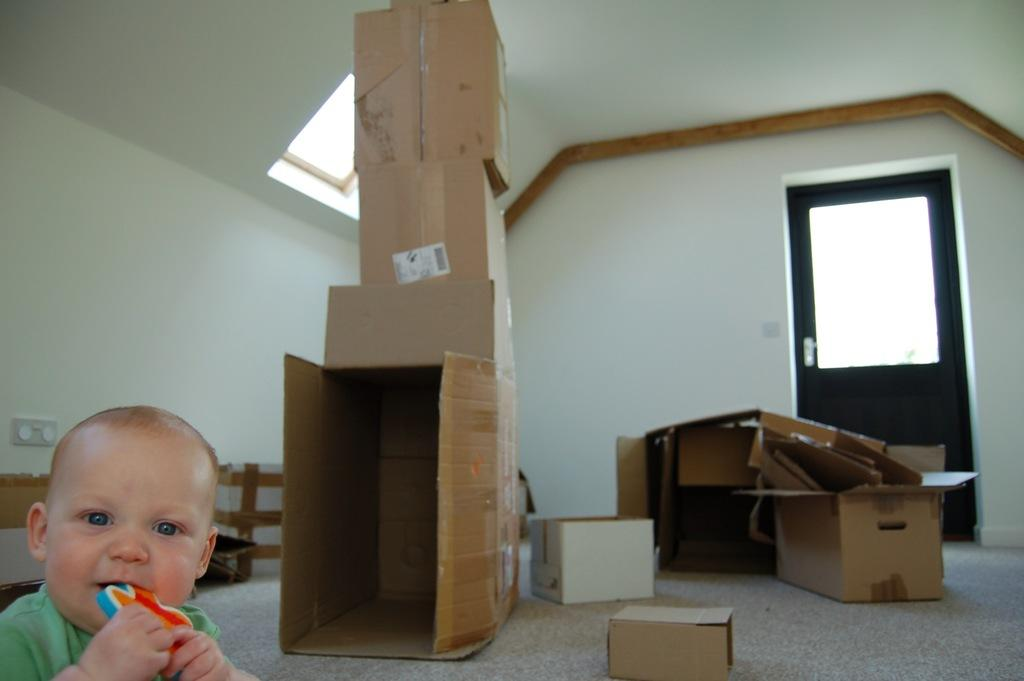What is the baby doing in the image? The baby is sitting on the floor in the image. What is the baby holding in the image? The baby is holding a toy in the image. What objects are placed on the floor in the image? There are cardboard boxes placed on the floor in the image. What can be seen in the background of the image? There is a door visible in the image, and a board is on a wall in the image. What part of the building can be seen in the image? The roof is visible in the image. What grade is the baby in, based on the image? There is no indication of the baby's grade in the image. What is the baby doing with their head in the image? There is no specific action involving the baby's head in the image. 